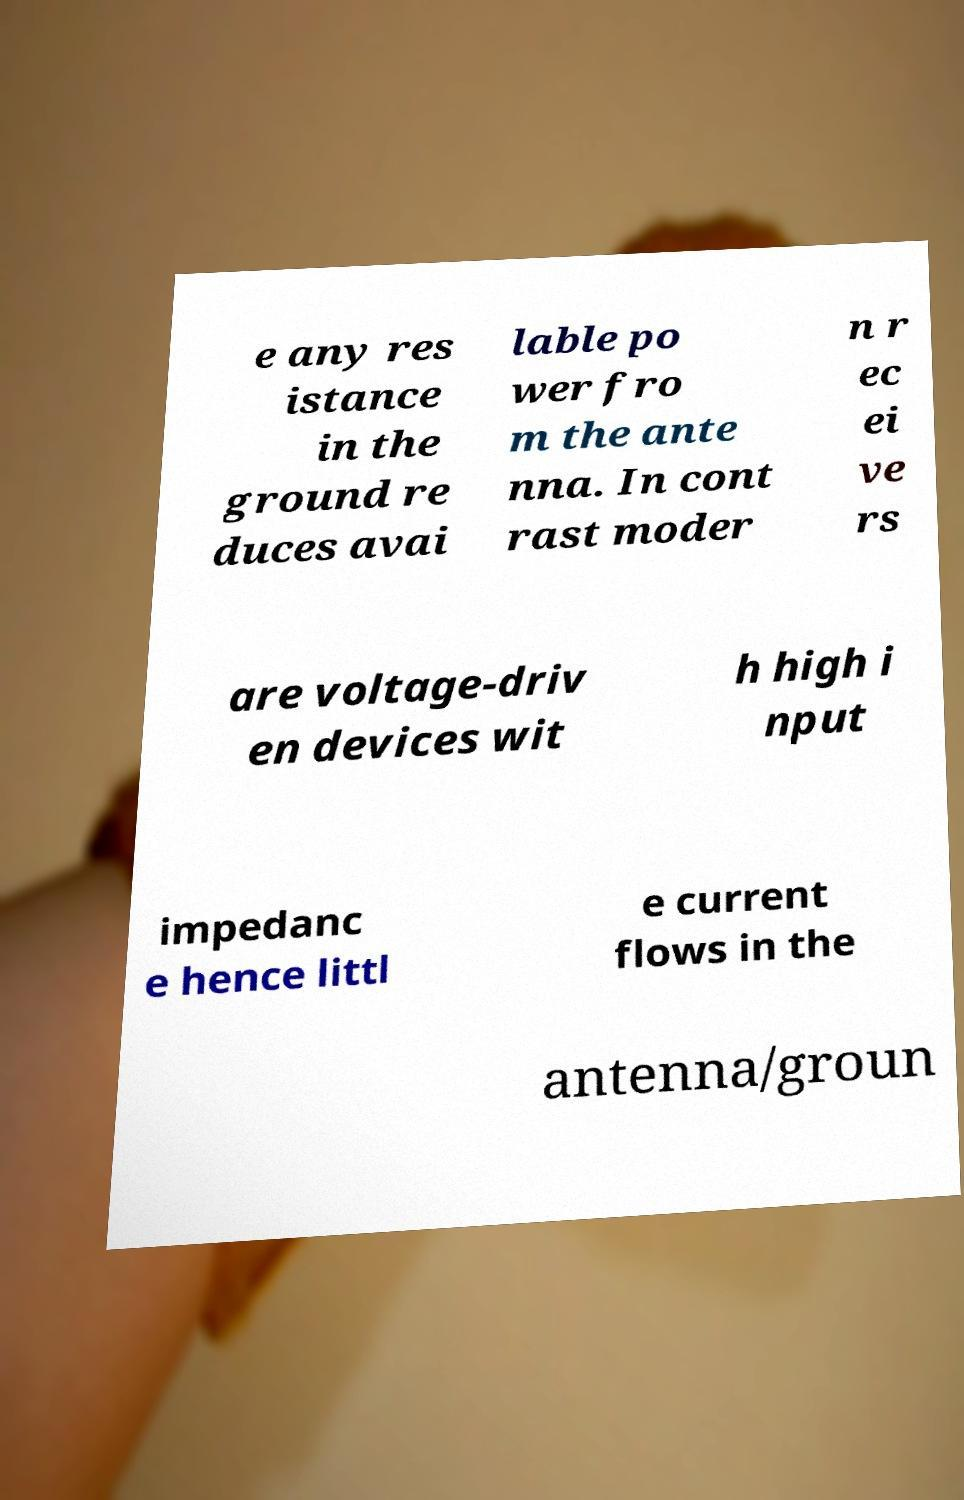Could you assist in decoding the text presented in this image and type it out clearly? e any res istance in the ground re duces avai lable po wer fro m the ante nna. In cont rast moder n r ec ei ve rs are voltage-driv en devices wit h high i nput impedanc e hence littl e current flows in the antenna/groun 